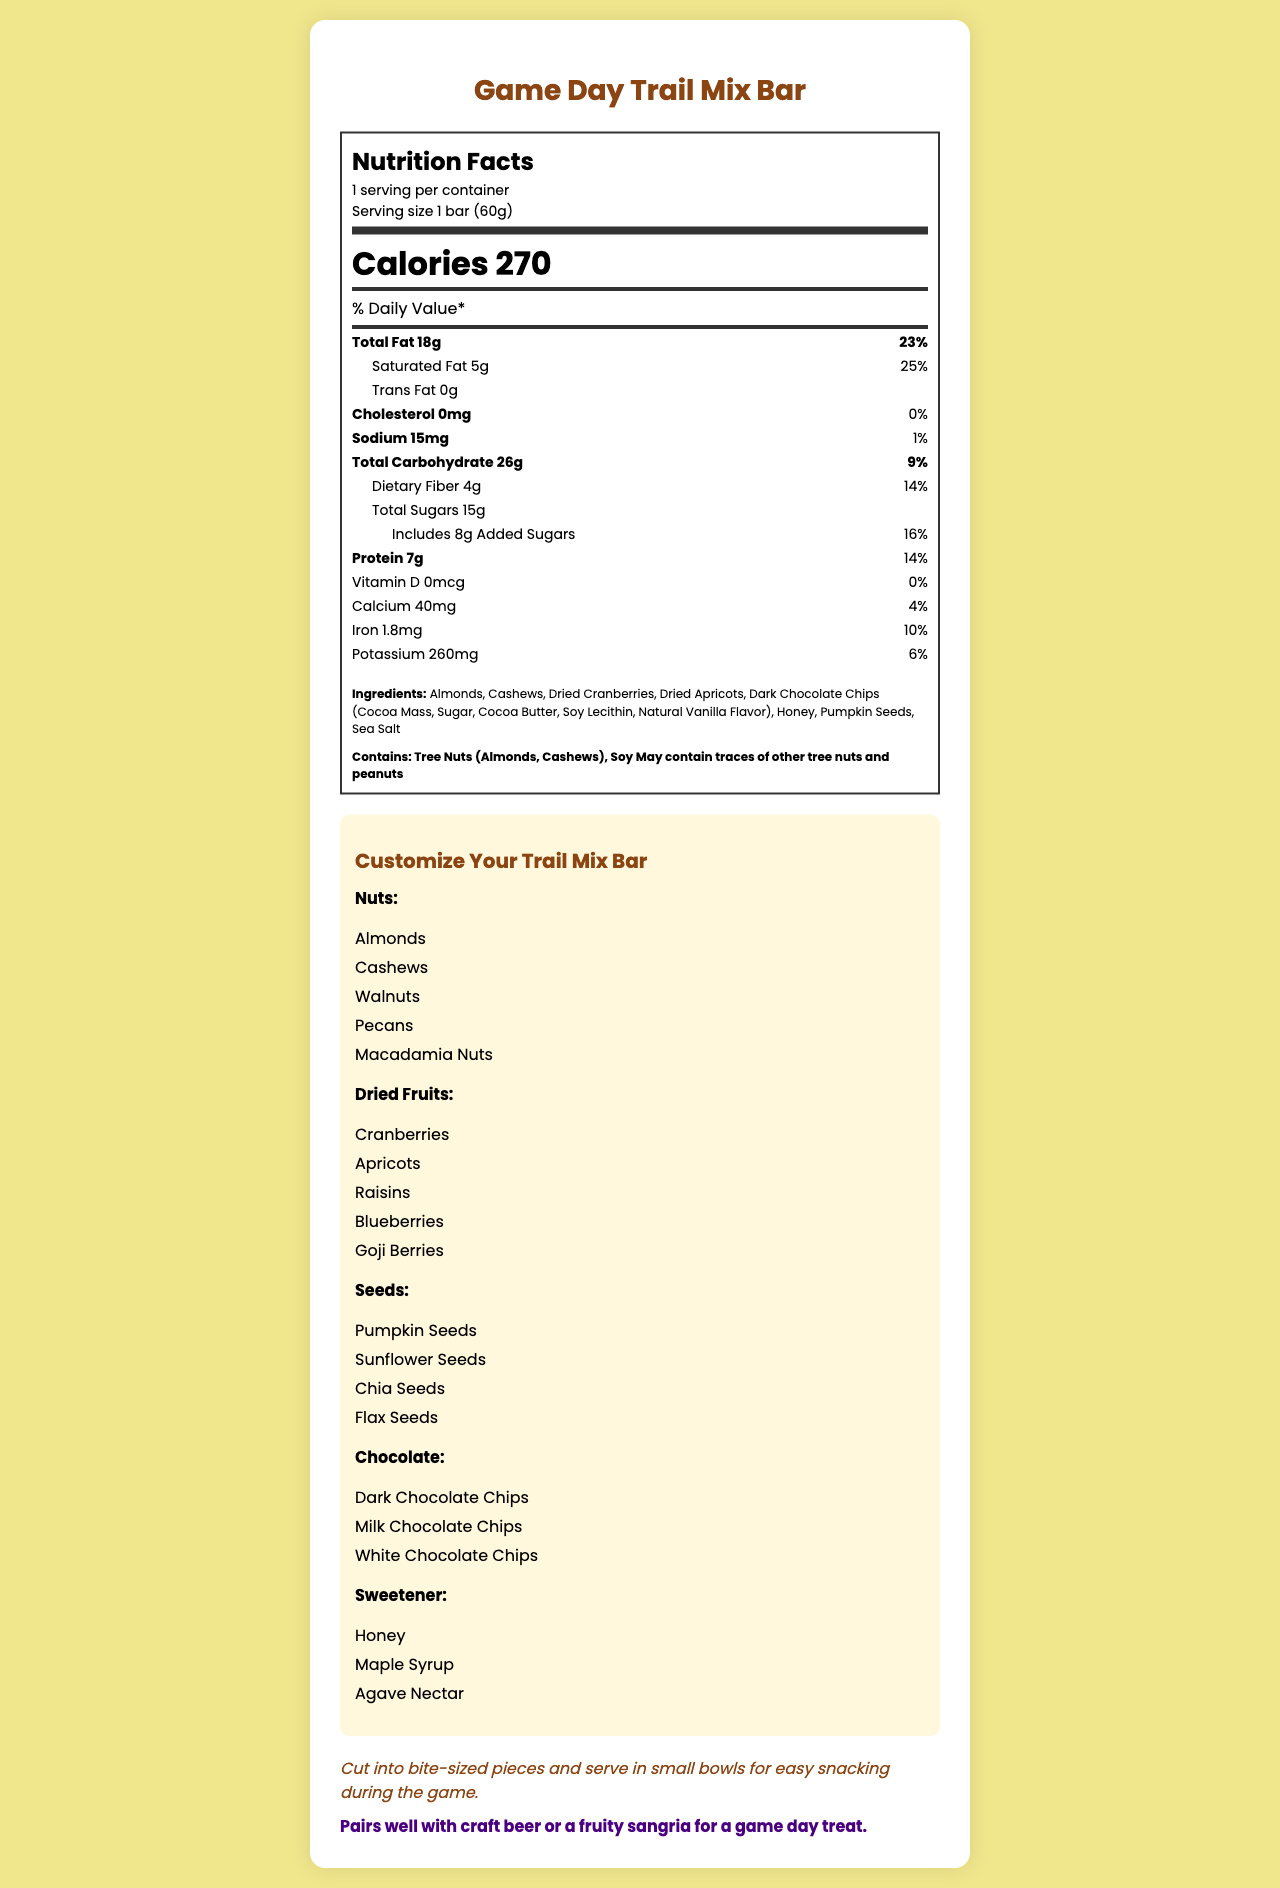What is the serving size for the Game Day Trail Mix Bar? The document specifies that the serving size is "1 bar (60g)".
Answer: 1 bar (60g) How many calories are in one serving of the trail mix bar? The document states that one serving contains 270 calories.
Answer: 270 What is the total fat content in the Game Day Trail Mix Bar? According to the Nutrition Facts, the total fat content is 18 grams.
Answer: 18g How much dietary fiber does one bar contain? The document mentions that one bar contains 4 grams of dietary fiber.
Answer: 4g What are the first three ingredients listed? The first three ingredients listed are Almonds, Cashews, and Dried Cranberries.
Answer: Almonds, Cashews, Dried Cranberries How much protein does the bar provide? The document indicates that the bar provides 7 grams of protein.
Answer: 7g Does the Game Day Trail Mix Bar contain any cholesterol? The Nutrition Facts state that the cholesterol amount is 0 mg.
Answer: No What are the allergen warnings for this product? The document specifies the allergen warnings under the "allergens" section.
Answer: Contains: Tree Nuts (Almonds, Cashews), Soy. May contain traces of other tree nuts and peanuts. Which of the following nutrients is not present in the Game Day Trail Mix Bar?
A. Vitamin D
B. Calcium
C. Iron The document lists Vitamin D with 0 mcg and 0% daily value, indicating it's not present.
Answer: A. Vitamin D Which type of seeds cannot be found in the customization options?
I. Pumpkin Seeds
II. Sunflower Seeds
III. Chia Seeds
IV. Sesame Seeds The customization options include Pumpkin Seeds, Sunflower Seeds, and Chia Seeds, but not Sesame Seeds.
Answer: IV. Sesame Seeds Can you customize the trail mix bar with Blueberries? (Yes/No) The customization options for dried fruits include Blueberries.
Answer: Yes Summarize the main idea of the document. The document comprehensively outlines nutritional information, ingredient details, possible allergens, and various ways to customize the trail mix bar. It also gives tips on how to serve and store the product, and suggests pairing it with beverages.
Answer: The document provides detailed nutrition facts, ingredients, allergen information, and customization options for the Game Day Trail Mix Bar. It also includes storage instructions, serving suggestions, and pairing recommendations. How should the Game Day Trail Mix Bar be stored after opening? The storage instructions in the document are to store it in a cool, dry place and to consume it within 2 weeks of opening.
Answer: Store in a cool, dry place. Best consumed within 2 weeks of opening. Which sweetener is not an option in the customization choices?
A. Honey
B. Maple Syrup
C. Agave Nectar
D. Brown Sugar The customization options for sweeteners include Honey, Maple Syrup, and Agave Nectar, but not Brown Sugar.
Answer: D. Brown Sugar What is the recommended pairing for this trail mix bar? The document recommends pairing the trail mix bar with craft beer or a fruity sangria.
Answer: Craft beer or a fruity sangria Is it possible to determine the sugar content of the dried fruits in the bar? The document lists the total sugars and added sugars but does not break down the sugar content of each individual ingredient such as the dried fruits.
Answer: Cannot be determined 